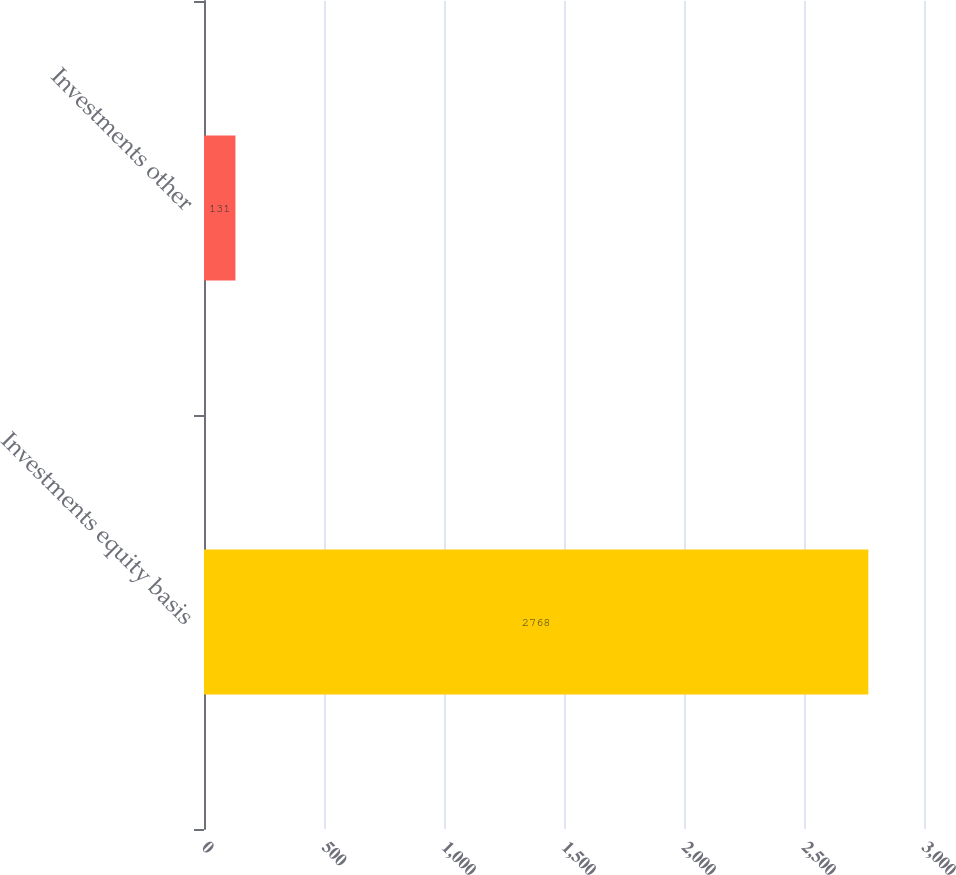Convert chart. <chart><loc_0><loc_0><loc_500><loc_500><bar_chart><fcel>Investments equity basis<fcel>Investments other<nl><fcel>2768<fcel>131<nl></chart> 